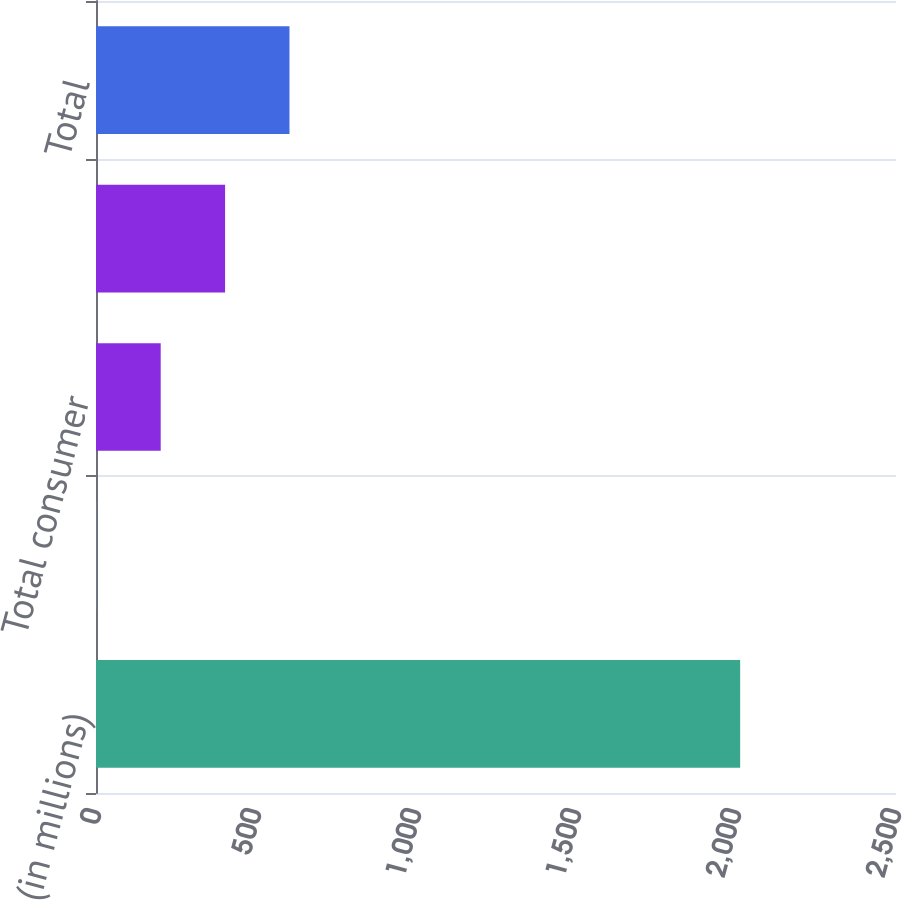<chart> <loc_0><loc_0><loc_500><loc_500><bar_chart><fcel>(in millions)<fcel>Consumer excluding credit card<fcel>Total consumer<fcel>Wholesale<fcel>Total<nl><fcel>2013<fcel>1<fcel>202.2<fcel>403.4<fcel>604.6<nl></chart> 